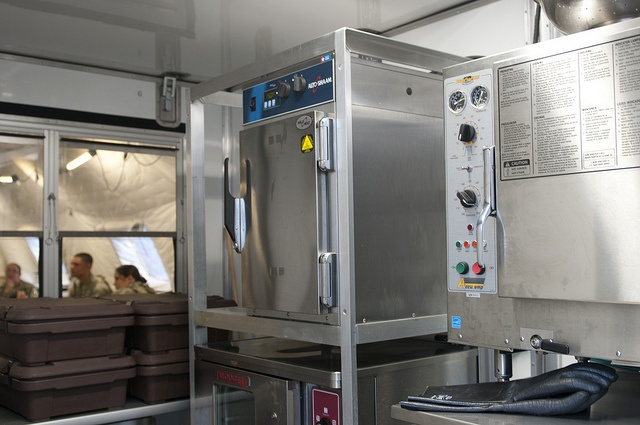Describe the objects in this image and their specific colors. I can see refrigerator in gray, darkgray, lightgray, and black tones, oven in gray, black, and maroon tones, bowl in gray, darkgray, and lightgray tones, people in gray, maroon, tan, and black tones, and people in gray, maroon, and black tones in this image. 